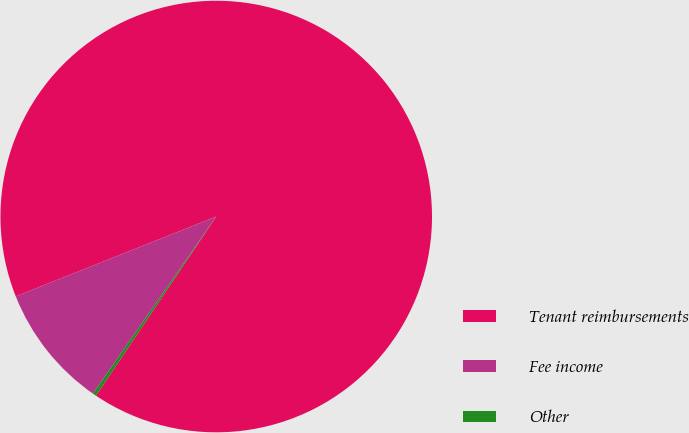Convert chart to OTSL. <chart><loc_0><loc_0><loc_500><loc_500><pie_chart><fcel>Tenant reimbursements<fcel>Fee income<fcel>Other<nl><fcel>90.44%<fcel>9.29%<fcel>0.27%<nl></chart> 